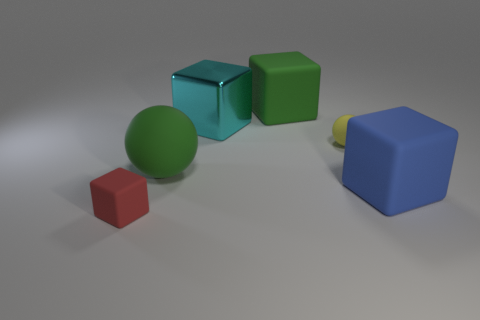Subtract all red matte cubes. How many cubes are left? 3 Add 1 tiny red matte cubes. How many objects exist? 7 Subtract all red cubes. How many cubes are left? 3 Subtract all blocks. How many objects are left? 2 Subtract 3 cubes. How many cubes are left? 1 Subtract all green balls. How many purple cubes are left? 0 Subtract all tiny red rubber things. Subtract all tiny things. How many objects are left? 3 Add 1 big cyan blocks. How many big cyan blocks are left? 2 Add 1 red objects. How many red objects exist? 2 Subtract 0 red balls. How many objects are left? 6 